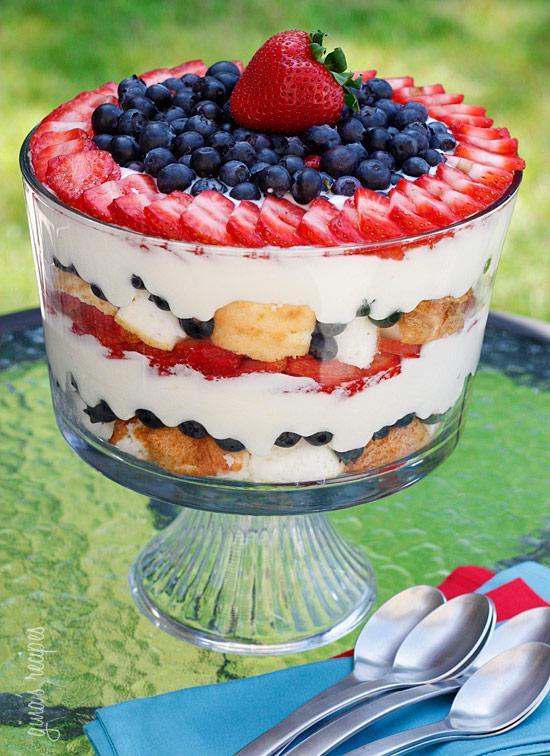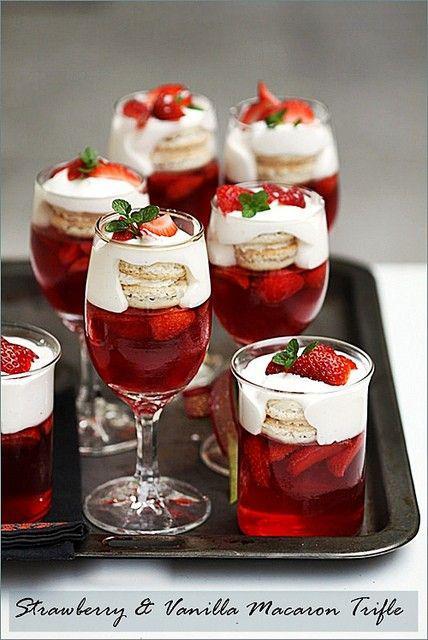The first image is the image on the left, the second image is the image on the right. Analyze the images presented: Is the assertion "In one image, a large dessert in a clear footed bowl is topped with a whole strawberry centered on a mound of blueberries, which are ringed by strawberry slices." valid? Answer yes or no. Yes. The first image is the image on the left, the second image is the image on the right. Examine the images to the left and right. Is the description "in one of the images, there is a strawberry nestled on top of a pile of blueberries on a cake" accurate? Answer yes or no. Yes. 